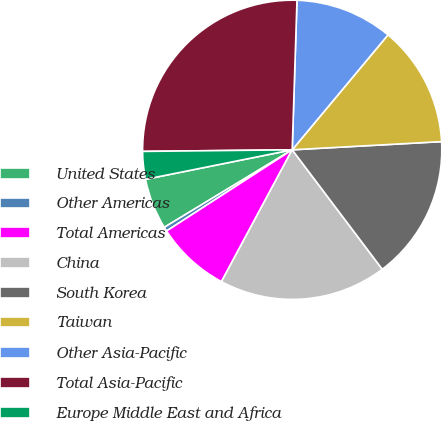Convert chart to OTSL. <chart><loc_0><loc_0><loc_500><loc_500><pie_chart><fcel>United States<fcel>Other Americas<fcel>Total Americas<fcel>China<fcel>South Korea<fcel>Taiwan<fcel>Other Asia-Pacific<fcel>Total Asia-Pacific<fcel>Europe Middle East and Africa<nl><fcel>5.51%<fcel>0.46%<fcel>8.03%<fcel>18.12%<fcel>15.59%<fcel>13.07%<fcel>10.55%<fcel>25.68%<fcel>2.99%<nl></chart> 